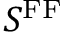Convert formula to latex. <formula><loc_0><loc_0><loc_500><loc_500>S ^ { F F }</formula> 